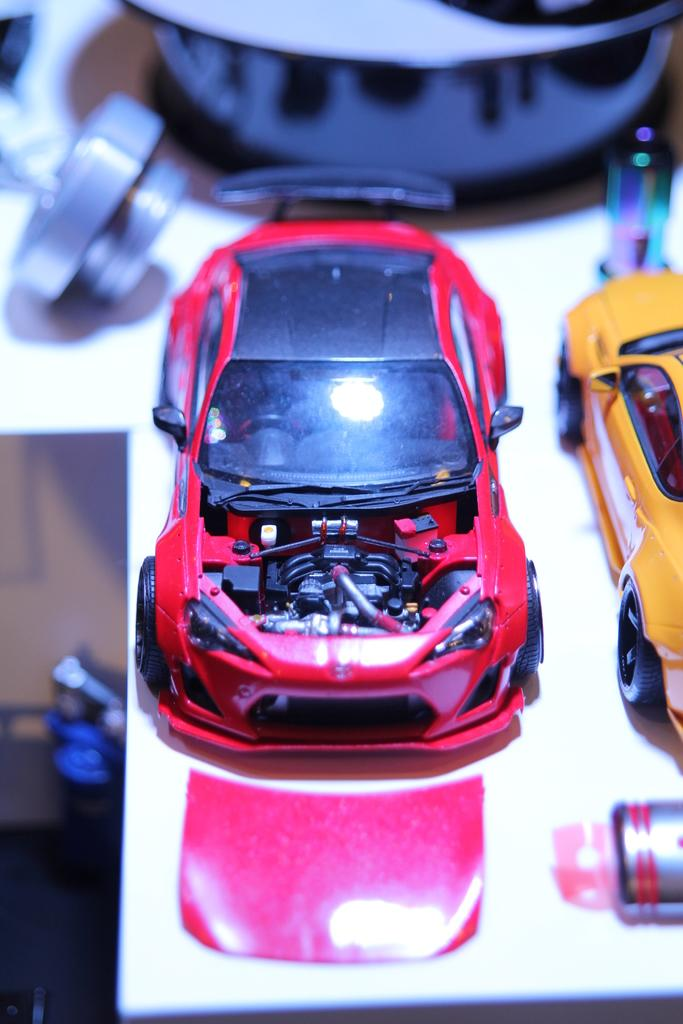What types of objects are in the image? There are two toy cars in the image. Can you describe the colors of the toy cars? One toy car is red in color, and the other toy car is yellow in color. How many goldfish are swimming in the image? There are no goldfish present in the image. What is the aftermath of the toy car race in the image? There is no toy car race depicted in the image, so it's not possible to determine the aftermath. 